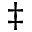<formula> <loc_0><loc_0><loc_500><loc_500>\ddagger</formula> 